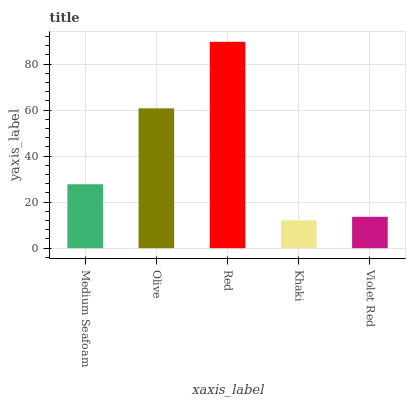Is Khaki the minimum?
Answer yes or no. Yes. Is Red the maximum?
Answer yes or no. Yes. Is Olive the minimum?
Answer yes or no. No. Is Olive the maximum?
Answer yes or no. No. Is Olive greater than Medium Seafoam?
Answer yes or no. Yes. Is Medium Seafoam less than Olive?
Answer yes or no. Yes. Is Medium Seafoam greater than Olive?
Answer yes or no. No. Is Olive less than Medium Seafoam?
Answer yes or no. No. Is Medium Seafoam the high median?
Answer yes or no. Yes. Is Medium Seafoam the low median?
Answer yes or no. Yes. Is Khaki the high median?
Answer yes or no. No. Is Olive the low median?
Answer yes or no. No. 